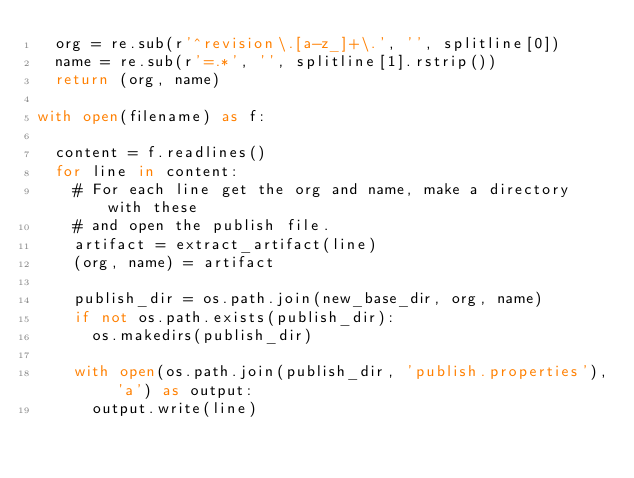<code> <loc_0><loc_0><loc_500><loc_500><_Python_>  org = re.sub(r'^revision\.[a-z_]+\.', '', splitline[0])
  name = re.sub(r'=.*', '', splitline[1].rstrip())
  return (org, name)

with open(filename) as f:

  content = f.readlines()
  for line in content:
    # For each line get the org and name, make a directory with these
    # and open the publish file.
    artifact = extract_artifact(line)
    (org, name) = artifact

    publish_dir = os.path.join(new_base_dir, org, name)
    if not os.path.exists(publish_dir):
      os.makedirs(publish_dir)

    with open(os.path.join(publish_dir, 'publish.properties'), 'a') as output:
      output.write(line)
</code> 